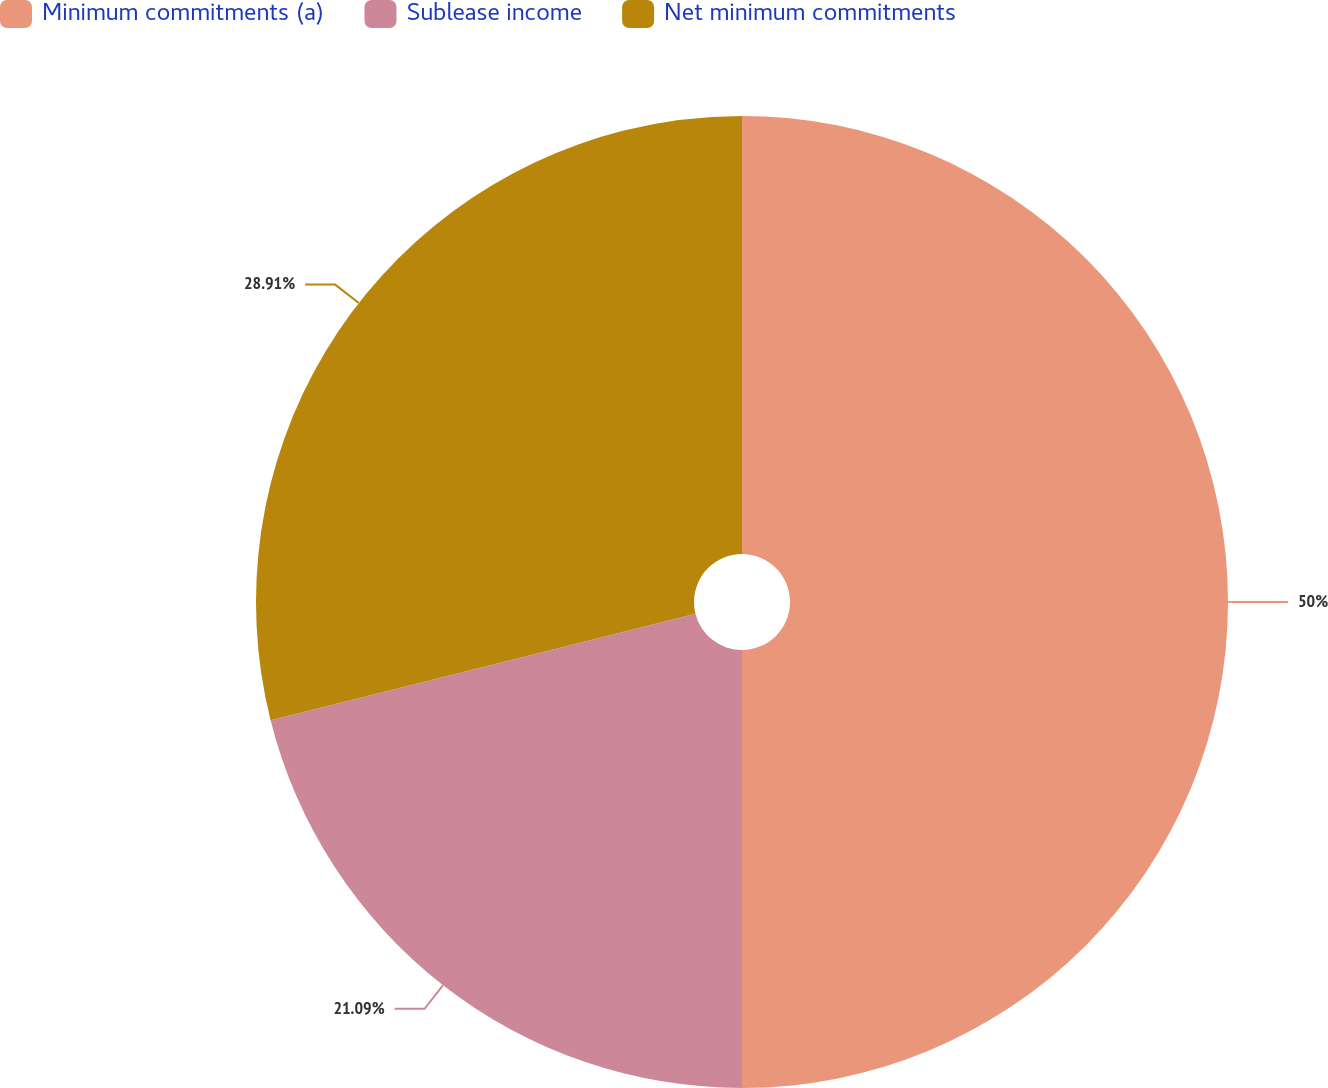<chart> <loc_0><loc_0><loc_500><loc_500><pie_chart><fcel>Minimum commitments (a)<fcel>Sublease income<fcel>Net minimum commitments<nl><fcel>50.0%<fcel>21.09%<fcel>28.91%<nl></chart> 